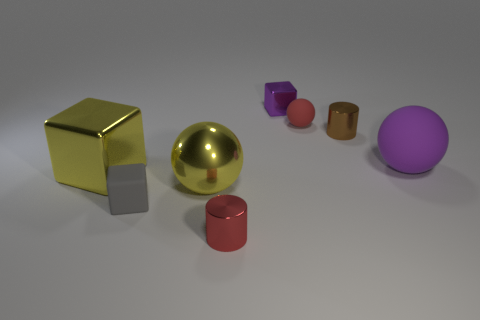Is the number of yellow blocks that are behind the yellow block the same as the number of purple cubes that are to the left of the red shiny thing?
Provide a succinct answer. Yes. How many large cyan blocks are made of the same material as the gray block?
Offer a terse response. 0. What shape is the large matte thing that is the same color as the small metallic cube?
Your answer should be compact. Sphere. There is a red thing that is behind the cube left of the gray cube; what is its size?
Make the answer very short. Small. Is the shape of the big purple matte thing that is on the right side of the tiny purple metal object the same as the matte thing that is in front of the big purple rubber sphere?
Keep it short and to the point. No. Is the number of tiny gray matte objects behind the purple shiny block the same as the number of purple spheres?
Provide a short and direct response. No. What is the color of the tiny object that is the same shape as the large matte object?
Keep it short and to the point. Red. Are the red object that is behind the purple rubber thing and the small gray object made of the same material?
Keep it short and to the point. Yes. How many big things are brown shiny cylinders or blue metallic cylinders?
Give a very brief answer. 0. What is the size of the red matte object?
Ensure brevity in your answer.  Small. 